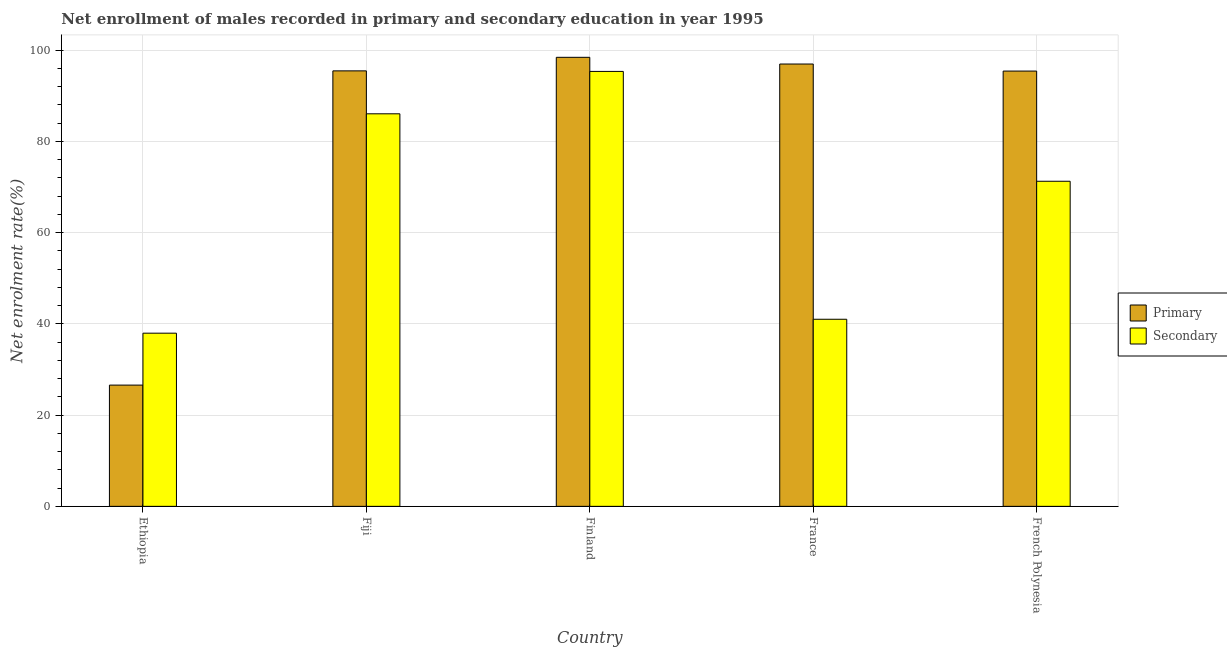How many groups of bars are there?
Keep it short and to the point. 5. In how many cases, is the number of bars for a given country not equal to the number of legend labels?
Your answer should be very brief. 0. What is the enrollment rate in secondary education in France?
Offer a very short reply. 41.01. Across all countries, what is the maximum enrollment rate in secondary education?
Ensure brevity in your answer.  95.33. Across all countries, what is the minimum enrollment rate in secondary education?
Make the answer very short. 37.95. In which country was the enrollment rate in primary education minimum?
Offer a very short reply. Ethiopia. What is the total enrollment rate in secondary education in the graph?
Offer a very short reply. 331.59. What is the difference between the enrollment rate in secondary education in Fiji and that in France?
Ensure brevity in your answer.  45.03. What is the difference between the enrollment rate in secondary education in France and the enrollment rate in primary education in Ethiopia?
Provide a succinct answer. 14.43. What is the average enrollment rate in primary education per country?
Ensure brevity in your answer.  82.56. What is the difference between the enrollment rate in secondary education and enrollment rate in primary education in French Polynesia?
Offer a very short reply. -24.15. What is the ratio of the enrollment rate in primary education in Ethiopia to that in French Polynesia?
Offer a terse response. 0.28. What is the difference between the highest and the second highest enrollment rate in primary education?
Your answer should be very brief. 1.47. What is the difference between the highest and the lowest enrollment rate in primary education?
Your response must be concise. 71.84. Is the sum of the enrollment rate in primary education in Ethiopia and Fiji greater than the maximum enrollment rate in secondary education across all countries?
Give a very brief answer. Yes. What does the 1st bar from the left in Finland represents?
Your answer should be compact. Primary. What does the 1st bar from the right in French Polynesia represents?
Ensure brevity in your answer.  Secondary. How many bars are there?
Ensure brevity in your answer.  10. Are the values on the major ticks of Y-axis written in scientific E-notation?
Your response must be concise. No. Where does the legend appear in the graph?
Ensure brevity in your answer.  Center right. How are the legend labels stacked?
Your response must be concise. Vertical. What is the title of the graph?
Give a very brief answer. Net enrollment of males recorded in primary and secondary education in year 1995. Does "IMF nonconcessional" appear as one of the legend labels in the graph?
Your answer should be compact. No. What is the label or title of the Y-axis?
Give a very brief answer. Net enrolment rate(%). What is the Net enrolment rate(%) in Primary in Ethiopia?
Ensure brevity in your answer.  26.58. What is the Net enrolment rate(%) in Secondary in Ethiopia?
Provide a succinct answer. 37.95. What is the Net enrolment rate(%) of Primary in Fiji?
Offer a very short reply. 95.45. What is the Net enrolment rate(%) of Secondary in Fiji?
Offer a very short reply. 86.04. What is the Net enrolment rate(%) in Primary in Finland?
Your answer should be compact. 98.42. What is the Net enrolment rate(%) in Secondary in Finland?
Offer a very short reply. 95.33. What is the Net enrolment rate(%) in Primary in France?
Offer a terse response. 96.95. What is the Net enrolment rate(%) of Secondary in France?
Your answer should be compact. 41.01. What is the Net enrolment rate(%) in Primary in French Polynesia?
Your answer should be compact. 95.41. What is the Net enrolment rate(%) of Secondary in French Polynesia?
Make the answer very short. 71.26. Across all countries, what is the maximum Net enrolment rate(%) of Primary?
Provide a short and direct response. 98.42. Across all countries, what is the maximum Net enrolment rate(%) in Secondary?
Your answer should be very brief. 95.33. Across all countries, what is the minimum Net enrolment rate(%) in Primary?
Offer a very short reply. 26.58. Across all countries, what is the minimum Net enrolment rate(%) of Secondary?
Offer a terse response. 37.95. What is the total Net enrolment rate(%) of Primary in the graph?
Your answer should be very brief. 412.81. What is the total Net enrolment rate(%) of Secondary in the graph?
Keep it short and to the point. 331.59. What is the difference between the Net enrolment rate(%) in Primary in Ethiopia and that in Fiji?
Make the answer very short. -68.87. What is the difference between the Net enrolment rate(%) of Secondary in Ethiopia and that in Fiji?
Keep it short and to the point. -48.08. What is the difference between the Net enrolment rate(%) of Primary in Ethiopia and that in Finland?
Your answer should be very brief. -71.84. What is the difference between the Net enrolment rate(%) of Secondary in Ethiopia and that in Finland?
Give a very brief answer. -57.38. What is the difference between the Net enrolment rate(%) of Primary in Ethiopia and that in France?
Your answer should be very brief. -70.38. What is the difference between the Net enrolment rate(%) in Secondary in Ethiopia and that in France?
Offer a terse response. -3.05. What is the difference between the Net enrolment rate(%) of Primary in Ethiopia and that in French Polynesia?
Your answer should be very brief. -68.83. What is the difference between the Net enrolment rate(%) of Secondary in Ethiopia and that in French Polynesia?
Your answer should be very brief. -33.3. What is the difference between the Net enrolment rate(%) of Primary in Fiji and that in Finland?
Offer a terse response. -2.97. What is the difference between the Net enrolment rate(%) in Secondary in Fiji and that in Finland?
Make the answer very short. -9.29. What is the difference between the Net enrolment rate(%) in Primary in Fiji and that in France?
Your answer should be compact. -1.5. What is the difference between the Net enrolment rate(%) of Secondary in Fiji and that in France?
Make the answer very short. 45.03. What is the difference between the Net enrolment rate(%) of Primary in Fiji and that in French Polynesia?
Your answer should be very brief. 0.04. What is the difference between the Net enrolment rate(%) in Secondary in Fiji and that in French Polynesia?
Ensure brevity in your answer.  14.78. What is the difference between the Net enrolment rate(%) in Primary in Finland and that in France?
Give a very brief answer. 1.47. What is the difference between the Net enrolment rate(%) in Secondary in Finland and that in France?
Make the answer very short. 54.33. What is the difference between the Net enrolment rate(%) in Primary in Finland and that in French Polynesia?
Keep it short and to the point. 3.01. What is the difference between the Net enrolment rate(%) in Secondary in Finland and that in French Polynesia?
Provide a short and direct response. 24.08. What is the difference between the Net enrolment rate(%) of Primary in France and that in French Polynesia?
Keep it short and to the point. 1.54. What is the difference between the Net enrolment rate(%) in Secondary in France and that in French Polynesia?
Your response must be concise. -30.25. What is the difference between the Net enrolment rate(%) in Primary in Ethiopia and the Net enrolment rate(%) in Secondary in Fiji?
Keep it short and to the point. -59.46. What is the difference between the Net enrolment rate(%) of Primary in Ethiopia and the Net enrolment rate(%) of Secondary in Finland?
Provide a short and direct response. -68.76. What is the difference between the Net enrolment rate(%) of Primary in Ethiopia and the Net enrolment rate(%) of Secondary in France?
Provide a succinct answer. -14.43. What is the difference between the Net enrolment rate(%) in Primary in Ethiopia and the Net enrolment rate(%) in Secondary in French Polynesia?
Offer a terse response. -44.68. What is the difference between the Net enrolment rate(%) of Primary in Fiji and the Net enrolment rate(%) of Secondary in Finland?
Offer a very short reply. 0.12. What is the difference between the Net enrolment rate(%) of Primary in Fiji and the Net enrolment rate(%) of Secondary in France?
Your answer should be compact. 54.44. What is the difference between the Net enrolment rate(%) in Primary in Fiji and the Net enrolment rate(%) in Secondary in French Polynesia?
Make the answer very short. 24.19. What is the difference between the Net enrolment rate(%) in Primary in Finland and the Net enrolment rate(%) in Secondary in France?
Offer a terse response. 57.41. What is the difference between the Net enrolment rate(%) in Primary in Finland and the Net enrolment rate(%) in Secondary in French Polynesia?
Make the answer very short. 27.16. What is the difference between the Net enrolment rate(%) of Primary in France and the Net enrolment rate(%) of Secondary in French Polynesia?
Keep it short and to the point. 25.69. What is the average Net enrolment rate(%) in Primary per country?
Offer a terse response. 82.56. What is the average Net enrolment rate(%) of Secondary per country?
Offer a very short reply. 66.32. What is the difference between the Net enrolment rate(%) of Primary and Net enrolment rate(%) of Secondary in Ethiopia?
Your response must be concise. -11.38. What is the difference between the Net enrolment rate(%) of Primary and Net enrolment rate(%) of Secondary in Fiji?
Provide a succinct answer. 9.41. What is the difference between the Net enrolment rate(%) in Primary and Net enrolment rate(%) in Secondary in Finland?
Provide a short and direct response. 3.09. What is the difference between the Net enrolment rate(%) in Primary and Net enrolment rate(%) in Secondary in France?
Provide a succinct answer. 55.94. What is the difference between the Net enrolment rate(%) of Primary and Net enrolment rate(%) of Secondary in French Polynesia?
Your answer should be compact. 24.15. What is the ratio of the Net enrolment rate(%) in Primary in Ethiopia to that in Fiji?
Keep it short and to the point. 0.28. What is the ratio of the Net enrolment rate(%) of Secondary in Ethiopia to that in Fiji?
Ensure brevity in your answer.  0.44. What is the ratio of the Net enrolment rate(%) of Primary in Ethiopia to that in Finland?
Make the answer very short. 0.27. What is the ratio of the Net enrolment rate(%) of Secondary in Ethiopia to that in Finland?
Ensure brevity in your answer.  0.4. What is the ratio of the Net enrolment rate(%) of Primary in Ethiopia to that in France?
Give a very brief answer. 0.27. What is the ratio of the Net enrolment rate(%) of Secondary in Ethiopia to that in France?
Your response must be concise. 0.93. What is the ratio of the Net enrolment rate(%) of Primary in Ethiopia to that in French Polynesia?
Make the answer very short. 0.28. What is the ratio of the Net enrolment rate(%) of Secondary in Ethiopia to that in French Polynesia?
Make the answer very short. 0.53. What is the ratio of the Net enrolment rate(%) of Primary in Fiji to that in Finland?
Offer a terse response. 0.97. What is the ratio of the Net enrolment rate(%) of Secondary in Fiji to that in Finland?
Offer a very short reply. 0.9. What is the ratio of the Net enrolment rate(%) of Primary in Fiji to that in France?
Your answer should be compact. 0.98. What is the ratio of the Net enrolment rate(%) in Secondary in Fiji to that in France?
Your response must be concise. 2.1. What is the ratio of the Net enrolment rate(%) of Secondary in Fiji to that in French Polynesia?
Offer a terse response. 1.21. What is the ratio of the Net enrolment rate(%) of Primary in Finland to that in France?
Provide a succinct answer. 1.02. What is the ratio of the Net enrolment rate(%) of Secondary in Finland to that in France?
Keep it short and to the point. 2.32. What is the ratio of the Net enrolment rate(%) of Primary in Finland to that in French Polynesia?
Your answer should be very brief. 1.03. What is the ratio of the Net enrolment rate(%) of Secondary in Finland to that in French Polynesia?
Give a very brief answer. 1.34. What is the ratio of the Net enrolment rate(%) in Primary in France to that in French Polynesia?
Your response must be concise. 1.02. What is the ratio of the Net enrolment rate(%) in Secondary in France to that in French Polynesia?
Keep it short and to the point. 0.58. What is the difference between the highest and the second highest Net enrolment rate(%) of Primary?
Your answer should be very brief. 1.47. What is the difference between the highest and the second highest Net enrolment rate(%) of Secondary?
Your response must be concise. 9.29. What is the difference between the highest and the lowest Net enrolment rate(%) of Primary?
Offer a very short reply. 71.84. What is the difference between the highest and the lowest Net enrolment rate(%) in Secondary?
Ensure brevity in your answer.  57.38. 